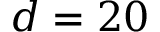<formula> <loc_0><loc_0><loc_500><loc_500>d = 2 0</formula> 